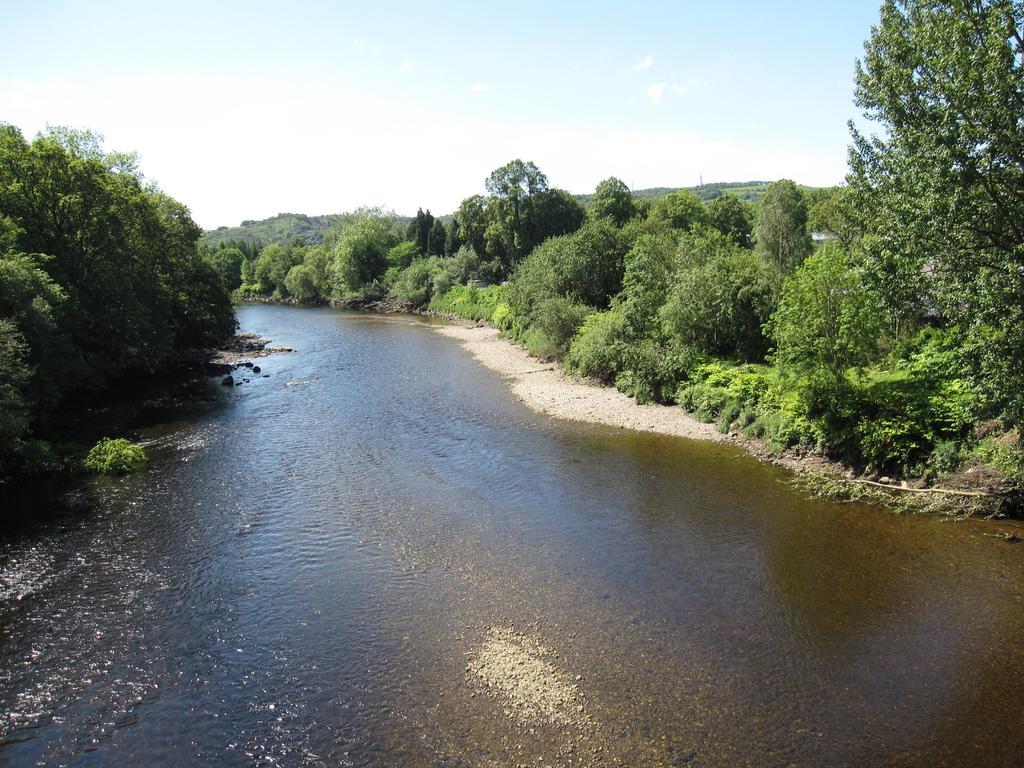In one or two sentences, can you explain what this image depicts? In this image we can see a river. On the sides of the river there are trees. In the background there is sky. 